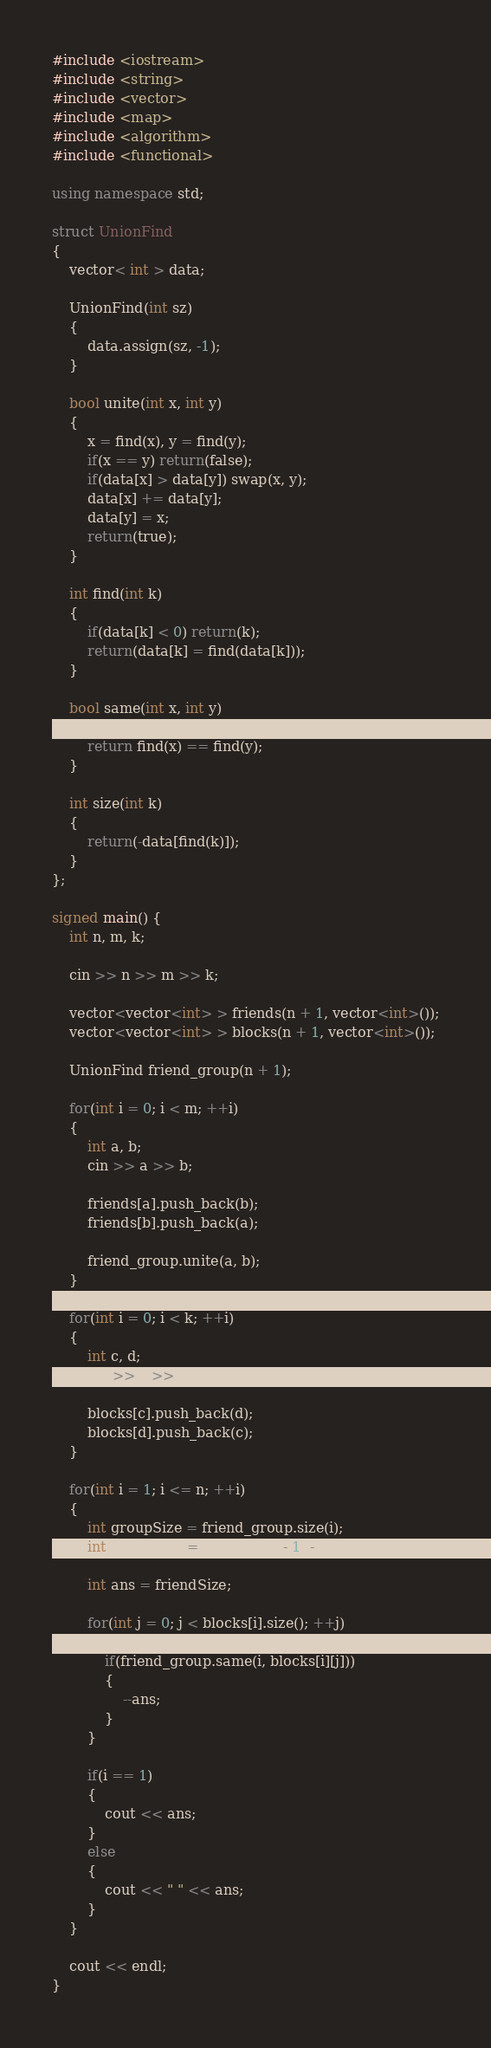<code> <loc_0><loc_0><loc_500><loc_500><_C++_>#include <iostream>
#include <string>
#include <vector>
#include <map>
#include <algorithm>
#include <functional>

using namespace std;

struct UnionFind
{
    vector< int > data;

    UnionFind(int sz)
    {
        data.assign(sz, -1);
    }

    bool unite(int x, int y)
    {
        x = find(x), y = find(y);
        if(x == y) return(false);
        if(data[x] > data[y]) swap(x, y);
        data[x] += data[y];
        data[y] = x;
        return(true);
    }

    int find(int k)
    {
        if(data[k] < 0) return(k);
        return(data[k] = find(data[k]));
    }

    bool same(int x, int y)
    {
        return find(x) == find(y);
    }

    int size(int k)
    {
        return(-data[find(k)]);
    }
};

signed main() {
    int n, m, k;

    cin >> n >> m >> k;

    vector<vector<int> > friends(n + 1, vector<int>());
    vector<vector<int> > blocks(n + 1, vector<int>());

    UnionFind friend_group(n + 1);

    for(int i = 0; i < m; ++i)
    {
        int a, b;
        cin >> a >> b;

        friends[a].push_back(b);
        friends[b].push_back(a);

        friend_group.unite(a, b);
    }

    for(int i = 0; i < k; ++i)
    {
        int c, d;
        cin >> c >> d;

        blocks[c].push_back(d);
        blocks[d].push_back(c);
    }

    for(int i = 1; i <= n; ++i)
    {
        int groupSize = friend_group.size(i);
        int friendSize = (groupSize - 1) - friends[i].size();

        int ans = friendSize;

        for(int j = 0; j < blocks[i].size(); ++j)
        {
            if(friend_group.same(i, blocks[i][j]))
            {
                --ans;
            }
        }

        if(i == 1)
        {
            cout << ans;
        }
        else
        {
            cout << " " << ans;
        }
    }
    
    cout << endl;
}</code> 